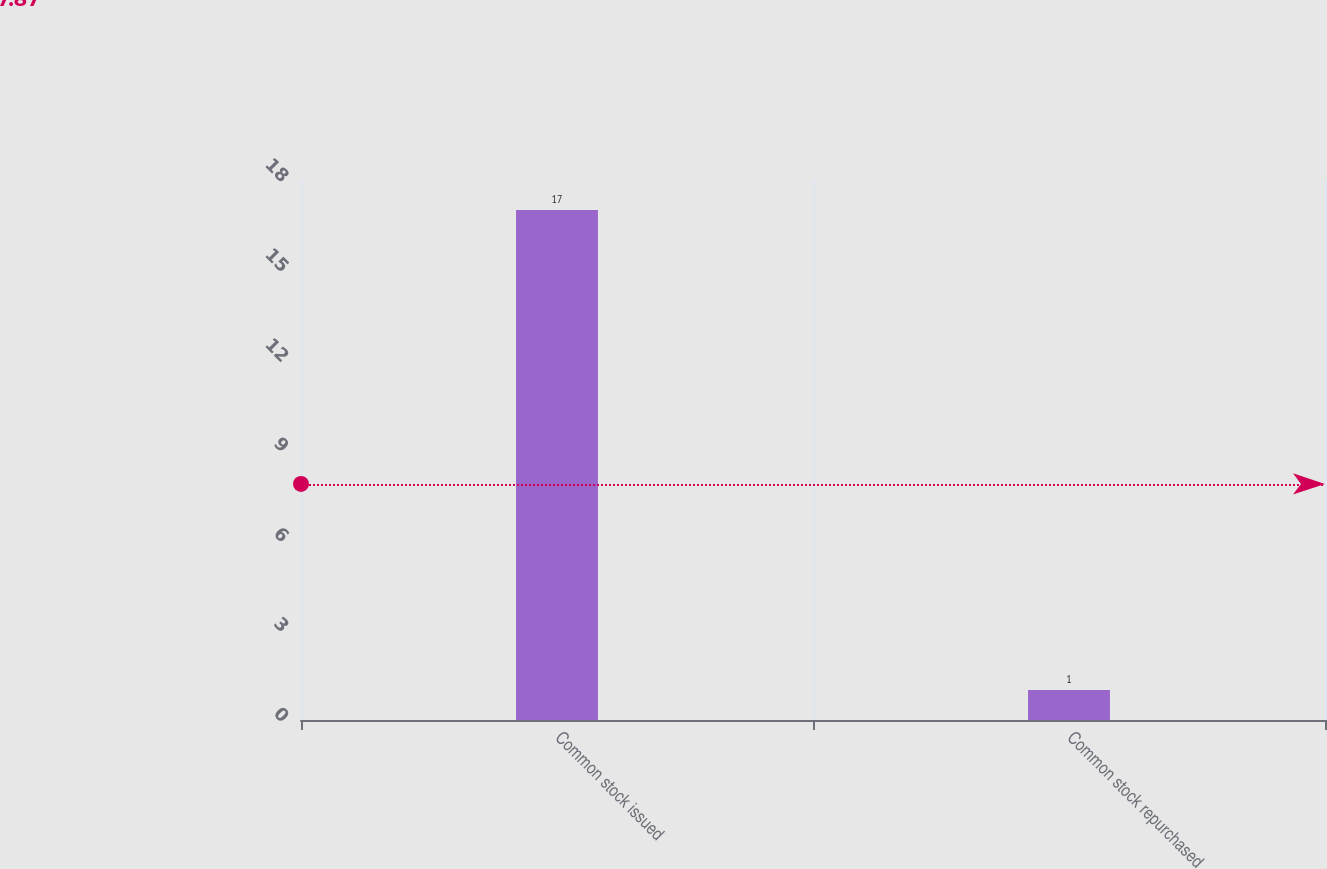Convert chart to OTSL. <chart><loc_0><loc_0><loc_500><loc_500><bar_chart><fcel>Common stock issued<fcel>Common stock repurchased<nl><fcel>17<fcel>1<nl></chart> 